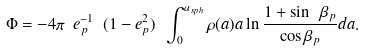Convert formula to latex. <formula><loc_0><loc_0><loc_500><loc_500>\Phi = - 4 \pi \ e _ { p } ^ { - 1 } \ ( 1 - e _ { p } ^ { 2 } ) \ \int _ { 0 } ^ { a _ { s p h } } \rho ( a ) a \ln \frac { 1 + \sin \ \beta _ { p } } { \cos \beta _ { p } } d a .</formula> 